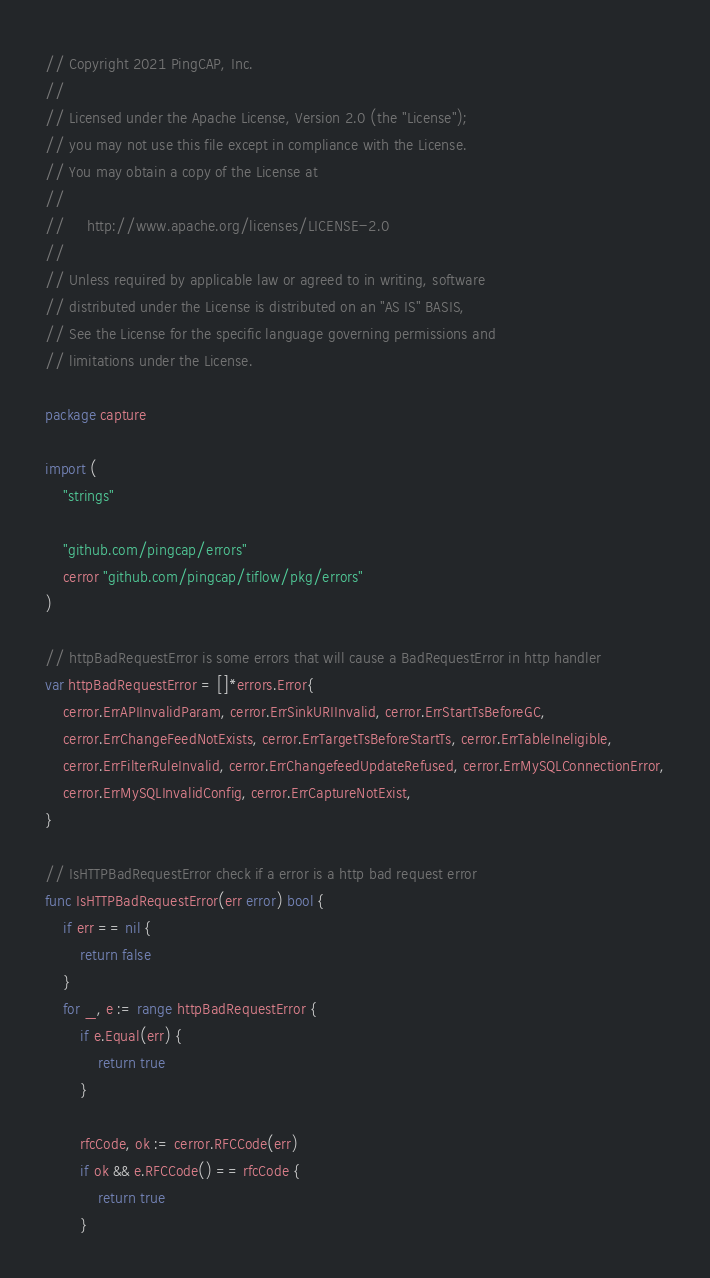Convert code to text. <code><loc_0><loc_0><loc_500><loc_500><_Go_>// Copyright 2021 PingCAP, Inc.
//
// Licensed under the Apache License, Version 2.0 (the "License");
// you may not use this file except in compliance with the License.
// You may obtain a copy of the License at
//
//     http://www.apache.org/licenses/LICENSE-2.0
//
// Unless required by applicable law or agreed to in writing, software
// distributed under the License is distributed on an "AS IS" BASIS,
// See the License for the specific language governing permissions and
// limitations under the License.

package capture

import (
	"strings"

	"github.com/pingcap/errors"
	cerror "github.com/pingcap/tiflow/pkg/errors"
)

// httpBadRequestError is some errors that will cause a BadRequestError in http handler
var httpBadRequestError = []*errors.Error{
	cerror.ErrAPIInvalidParam, cerror.ErrSinkURIInvalid, cerror.ErrStartTsBeforeGC,
	cerror.ErrChangeFeedNotExists, cerror.ErrTargetTsBeforeStartTs, cerror.ErrTableIneligible,
	cerror.ErrFilterRuleInvalid, cerror.ErrChangefeedUpdateRefused, cerror.ErrMySQLConnectionError,
	cerror.ErrMySQLInvalidConfig, cerror.ErrCaptureNotExist,
}

// IsHTTPBadRequestError check if a error is a http bad request error
func IsHTTPBadRequestError(err error) bool {
	if err == nil {
		return false
	}
	for _, e := range httpBadRequestError {
		if e.Equal(err) {
			return true
		}

		rfcCode, ok := cerror.RFCCode(err)
		if ok && e.RFCCode() == rfcCode {
			return true
		}
</code> 